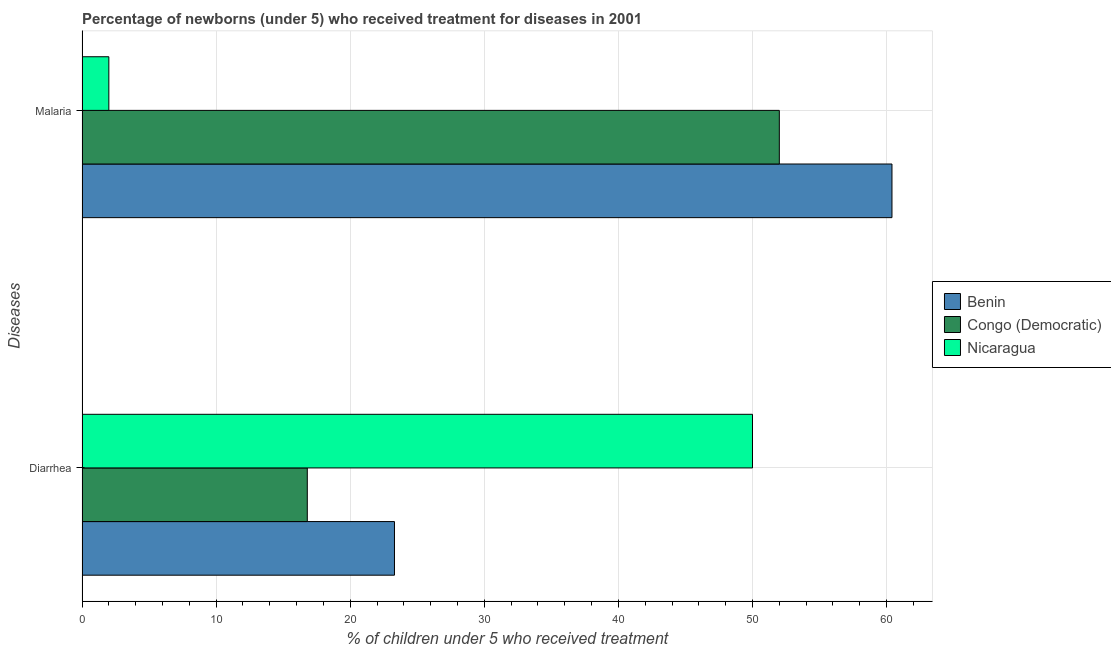Are the number of bars on each tick of the Y-axis equal?
Your answer should be very brief. Yes. How many bars are there on the 2nd tick from the top?
Give a very brief answer. 3. How many bars are there on the 1st tick from the bottom?
Ensure brevity in your answer.  3. What is the label of the 2nd group of bars from the top?
Provide a succinct answer. Diarrhea. Across all countries, what is the maximum percentage of children who received treatment for malaria?
Your response must be concise. 60.4. Across all countries, what is the minimum percentage of children who received treatment for diarrhoea?
Your answer should be very brief. 16.8. In which country was the percentage of children who received treatment for diarrhoea maximum?
Ensure brevity in your answer.  Nicaragua. In which country was the percentage of children who received treatment for diarrhoea minimum?
Your answer should be very brief. Congo (Democratic). What is the total percentage of children who received treatment for malaria in the graph?
Make the answer very short. 114.4. What is the difference between the percentage of children who received treatment for malaria in Nicaragua and that in Benin?
Offer a terse response. -58.4. What is the difference between the percentage of children who received treatment for malaria in Congo (Democratic) and the percentage of children who received treatment for diarrhoea in Nicaragua?
Give a very brief answer. 2. What is the average percentage of children who received treatment for diarrhoea per country?
Offer a very short reply. 30.03. What is the difference between the percentage of children who received treatment for malaria and percentage of children who received treatment for diarrhoea in Nicaragua?
Give a very brief answer. -48. What is the ratio of the percentage of children who received treatment for diarrhoea in Nicaragua to that in Benin?
Make the answer very short. 2.15. Is the percentage of children who received treatment for diarrhoea in Congo (Democratic) less than that in Nicaragua?
Give a very brief answer. Yes. What does the 1st bar from the top in Diarrhea represents?
Your response must be concise. Nicaragua. What does the 1st bar from the bottom in Malaria represents?
Your response must be concise. Benin. How many bars are there?
Make the answer very short. 6. Are all the bars in the graph horizontal?
Offer a terse response. Yes. Does the graph contain any zero values?
Make the answer very short. No. How many legend labels are there?
Ensure brevity in your answer.  3. How are the legend labels stacked?
Offer a terse response. Vertical. What is the title of the graph?
Keep it short and to the point. Percentage of newborns (under 5) who received treatment for diseases in 2001. What is the label or title of the X-axis?
Provide a succinct answer. % of children under 5 who received treatment. What is the label or title of the Y-axis?
Give a very brief answer. Diseases. What is the % of children under 5 who received treatment in Benin in Diarrhea?
Your answer should be very brief. 23.3. What is the % of children under 5 who received treatment of Benin in Malaria?
Give a very brief answer. 60.4. What is the % of children under 5 who received treatment of Congo (Democratic) in Malaria?
Your answer should be very brief. 52. Across all Diseases, what is the maximum % of children under 5 who received treatment of Benin?
Give a very brief answer. 60.4. Across all Diseases, what is the minimum % of children under 5 who received treatment of Benin?
Keep it short and to the point. 23.3. Across all Diseases, what is the minimum % of children under 5 who received treatment in Nicaragua?
Keep it short and to the point. 2. What is the total % of children under 5 who received treatment of Benin in the graph?
Provide a succinct answer. 83.7. What is the total % of children under 5 who received treatment of Congo (Democratic) in the graph?
Your answer should be compact. 68.8. What is the difference between the % of children under 5 who received treatment in Benin in Diarrhea and that in Malaria?
Offer a terse response. -37.1. What is the difference between the % of children under 5 who received treatment of Congo (Democratic) in Diarrhea and that in Malaria?
Offer a very short reply. -35.2. What is the difference between the % of children under 5 who received treatment in Nicaragua in Diarrhea and that in Malaria?
Provide a short and direct response. 48. What is the difference between the % of children under 5 who received treatment in Benin in Diarrhea and the % of children under 5 who received treatment in Congo (Democratic) in Malaria?
Give a very brief answer. -28.7. What is the difference between the % of children under 5 who received treatment of Benin in Diarrhea and the % of children under 5 who received treatment of Nicaragua in Malaria?
Give a very brief answer. 21.3. What is the average % of children under 5 who received treatment in Benin per Diseases?
Ensure brevity in your answer.  41.85. What is the average % of children under 5 who received treatment in Congo (Democratic) per Diseases?
Provide a succinct answer. 34.4. What is the average % of children under 5 who received treatment of Nicaragua per Diseases?
Keep it short and to the point. 26. What is the difference between the % of children under 5 who received treatment of Benin and % of children under 5 who received treatment of Nicaragua in Diarrhea?
Offer a very short reply. -26.7. What is the difference between the % of children under 5 who received treatment in Congo (Democratic) and % of children under 5 who received treatment in Nicaragua in Diarrhea?
Offer a terse response. -33.2. What is the difference between the % of children under 5 who received treatment of Benin and % of children under 5 who received treatment of Nicaragua in Malaria?
Your response must be concise. 58.4. What is the difference between the % of children under 5 who received treatment of Congo (Democratic) and % of children under 5 who received treatment of Nicaragua in Malaria?
Keep it short and to the point. 50. What is the ratio of the % of children under 5 who received treatment in Benin in Diarrhea to that in Malaria?
Your response must be concise. 0.39. What is the ratio of the % of children under 5 who received treatment of Congo (Democratic) in Diarrhea to that in Malaria?
Give a very brief answer. 0.32. What is the ratio of the % of children under 5 who received treatment in Nicaragua in Diarrhea to that in Malaria?
Provide a short and direct response. 25. What is the difference between the highest and the second highest % of children under 5 who received treatment in Benin?
Provide a short and direct response. 37.1. What is the difference between the highest and the second highest % of children under 5 who received treatment in Congo (Democratic)?
Give a very brief answer. 35.2. What is the difference between the highest and the lowest % of children under 5 who received treatment in Benin?
Your answer should be very brief. 37.1. What is the difference between the highest and the lowest % of children under 5 who received treatment in Congo (Democratic)?
Provide a succinct answer. 35.2. 